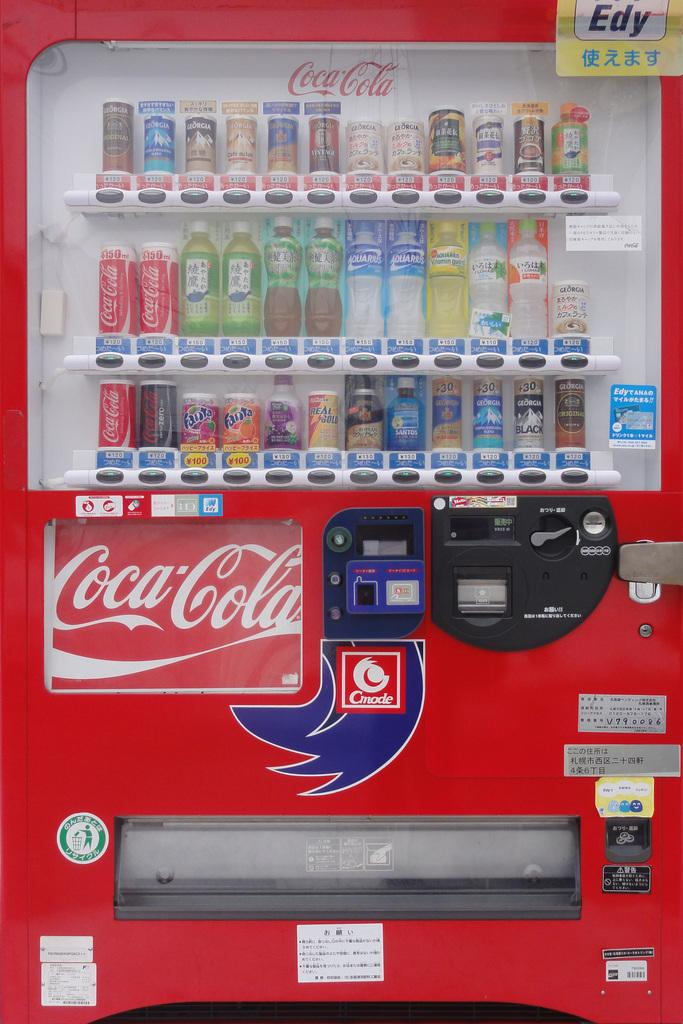<image>
Write a terse but informative summary of the picture. A Coca Cola machine that is filled with cans of soda and bottles of water. 